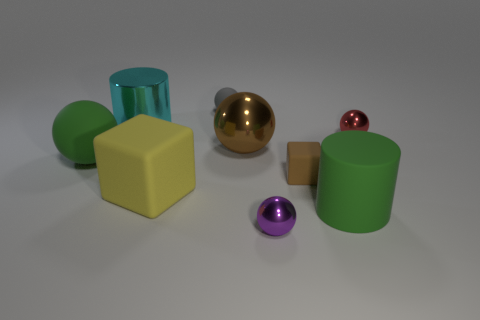What materials do the objects in the image appear to be made of? The objects in the image seem to imitate various materials. The large green cylinder and the small brown block have a matte appearance suggesting a possible plastic or painted wood construction. The large golden ball has a reflective surface characteristic of a metallic finish, while the small purple and red spheres could be interpreted as polished stone or colored glass due to their shiny surfaces. 